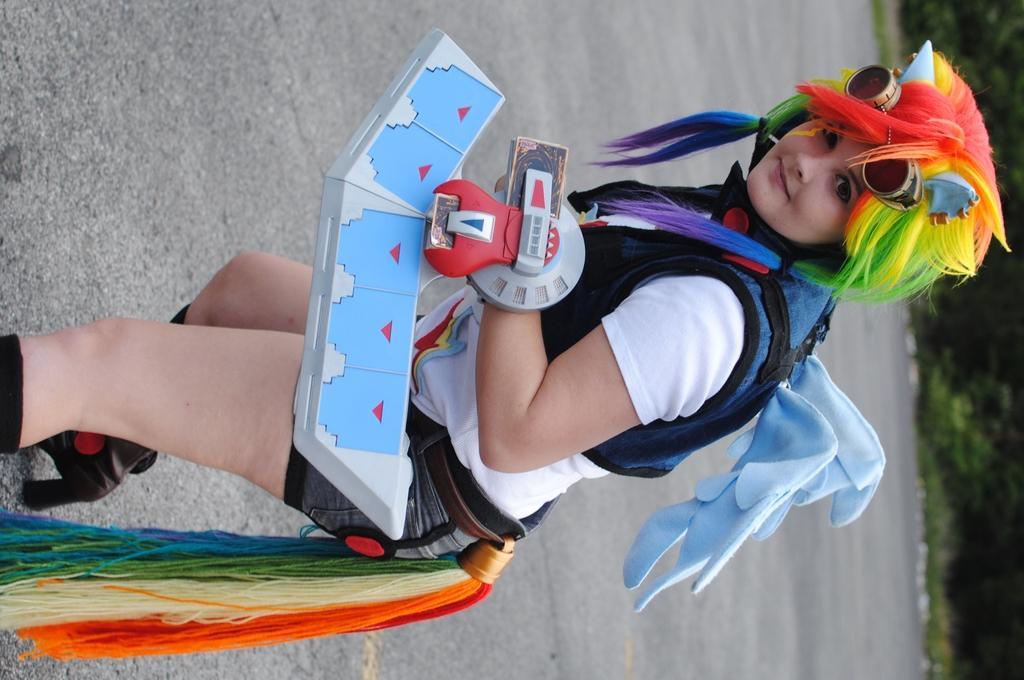Please provide a concise description of this image. In the image there is a woman in a cosplay attire and colorful wig standing on road, behind her there are trees, this is a vertical image. 